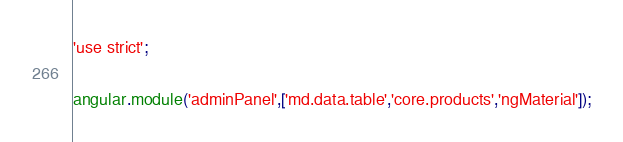Convert code to text. <code><loc_0><loc_0><loc_500><loc_500><_JavaScript_>'use strict';

angular.module('adminPanel',['md.data.table','core.products','ngMaterial']);</code> 